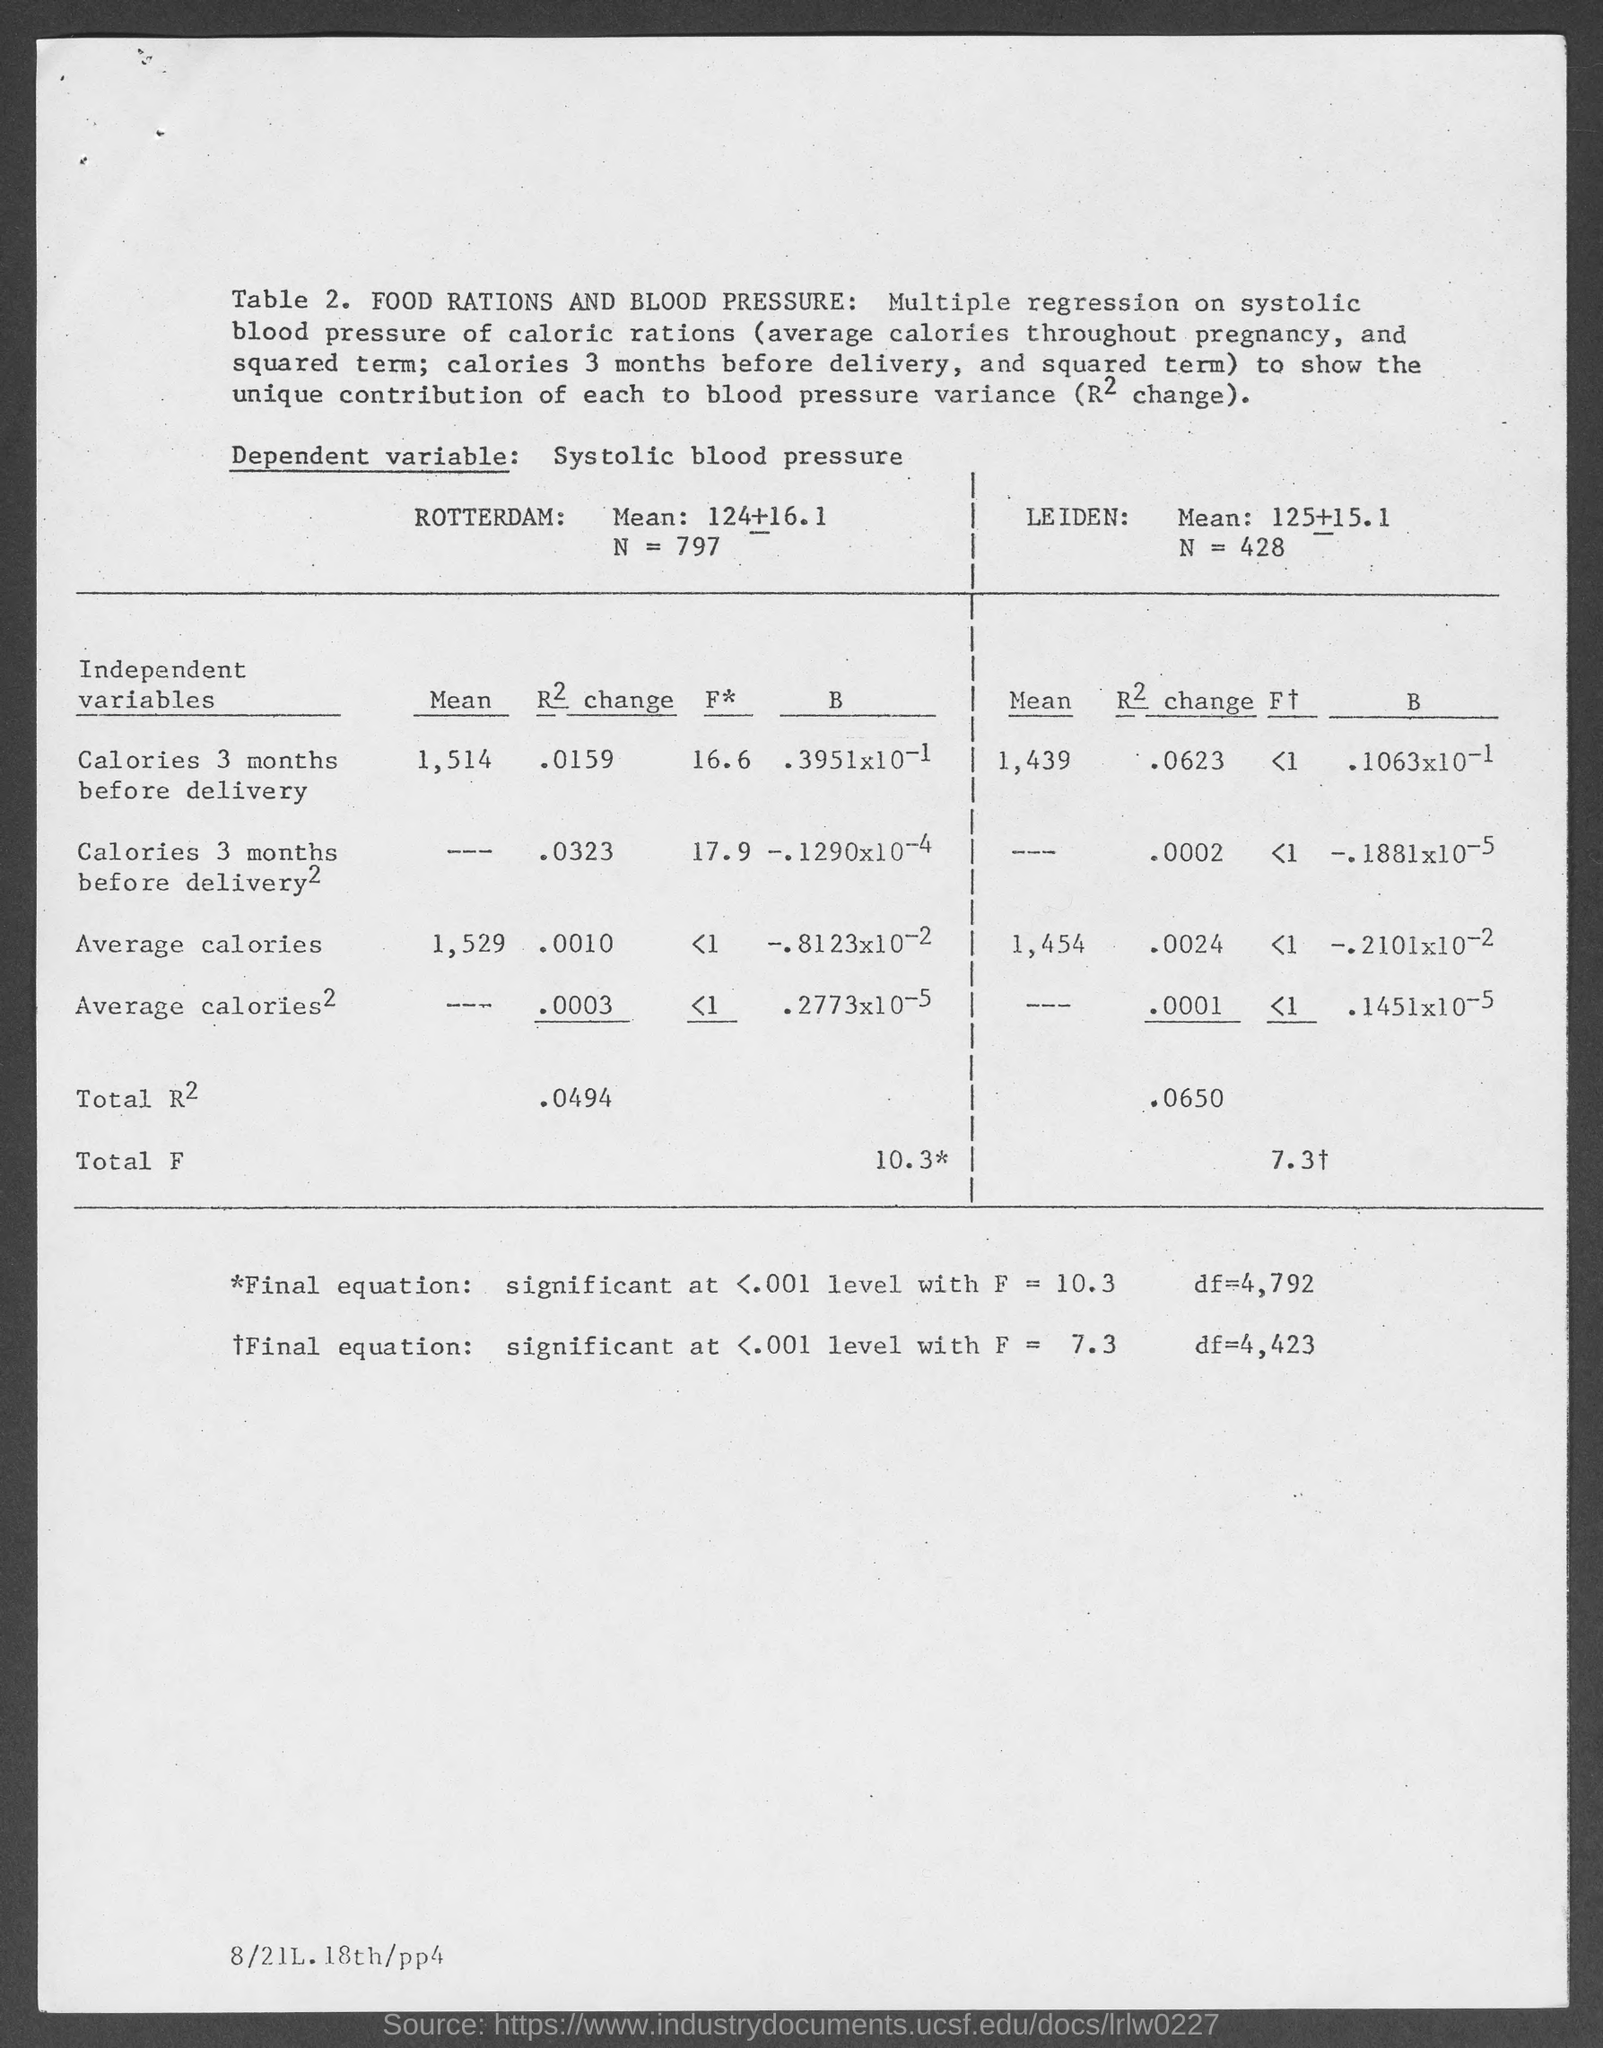What is the mean for calories 3 months before delivery for Rotterdam?
Provide a short and direct response. 1,514. What is the mean for calories 3 months before delivery for leiden?
Provide a short and direct response. 1,439. What is the R2 Change for calories 3 months before delivery for Rotterdam?
Ensure brevity in your answer.  .0159. What is the R2 Change for calories 3 months before delivery for Leiden?
Make the answer very short. .0623. 